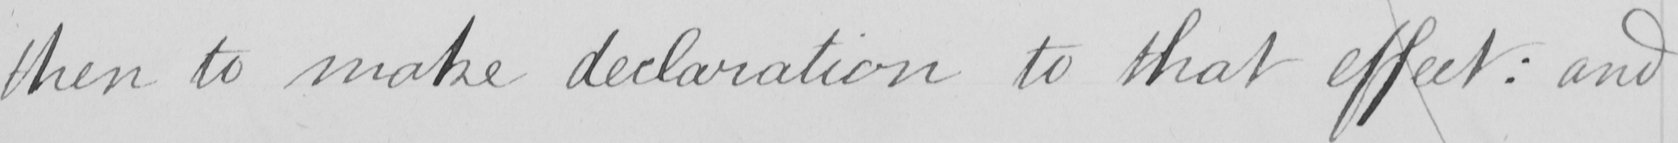What is written in this line of handwriting? then to make declaration to that effect  :  and 